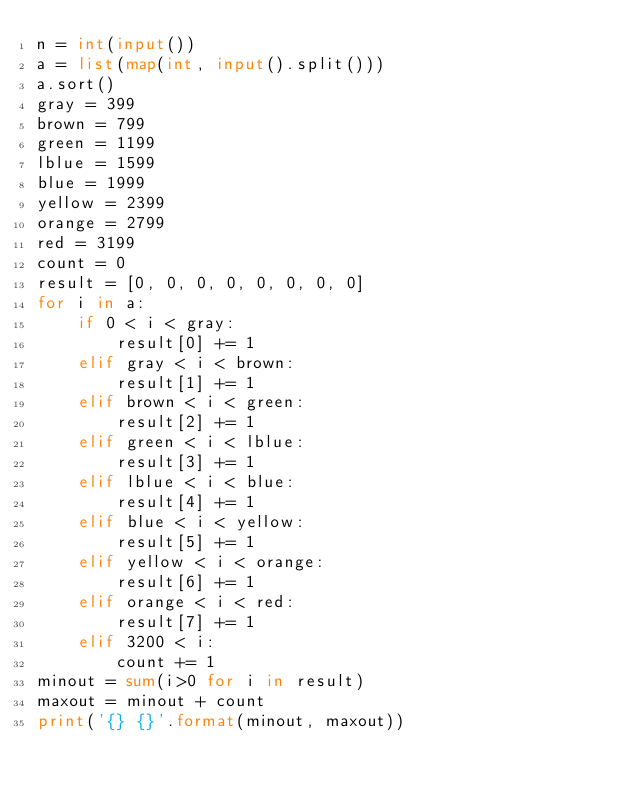Convert code to text. <code><loc_0><loc_0><loc_500><loc_500><_Python_>n = int(input())
a = list(map(int, input().split()))
a.sort()
gray = 399
brown = 799
green = 1199
lblue = 1599
blue = 1999
yellow = 2399
orange = 2799
red = 3199
count = 0
result = [0, 0, 0, 0, 0, 0, 0, 0]
for i in a:
    if 0 < i < gray:
        result[0] += 1
    elif gray < i < brown:
        result[1] += 1
    elif brown < i < green:
        result[2] += 1
    elif green < i < lblue:
        result[3] += 1
    elif lblue < i < blue:
        result[4] += 1
    elif blue < i < yellow:
        result[5] += 1
    elif yellow < i < orange:
        result[6] += 1
    elif orange < i < red:
        result[7] += 1
    elif 3200 < i:
        count += 1
minout = sum(i>0 for i in result)
maxout = minout + count
print('{} {}'.format(minout, maxout))
</code> 